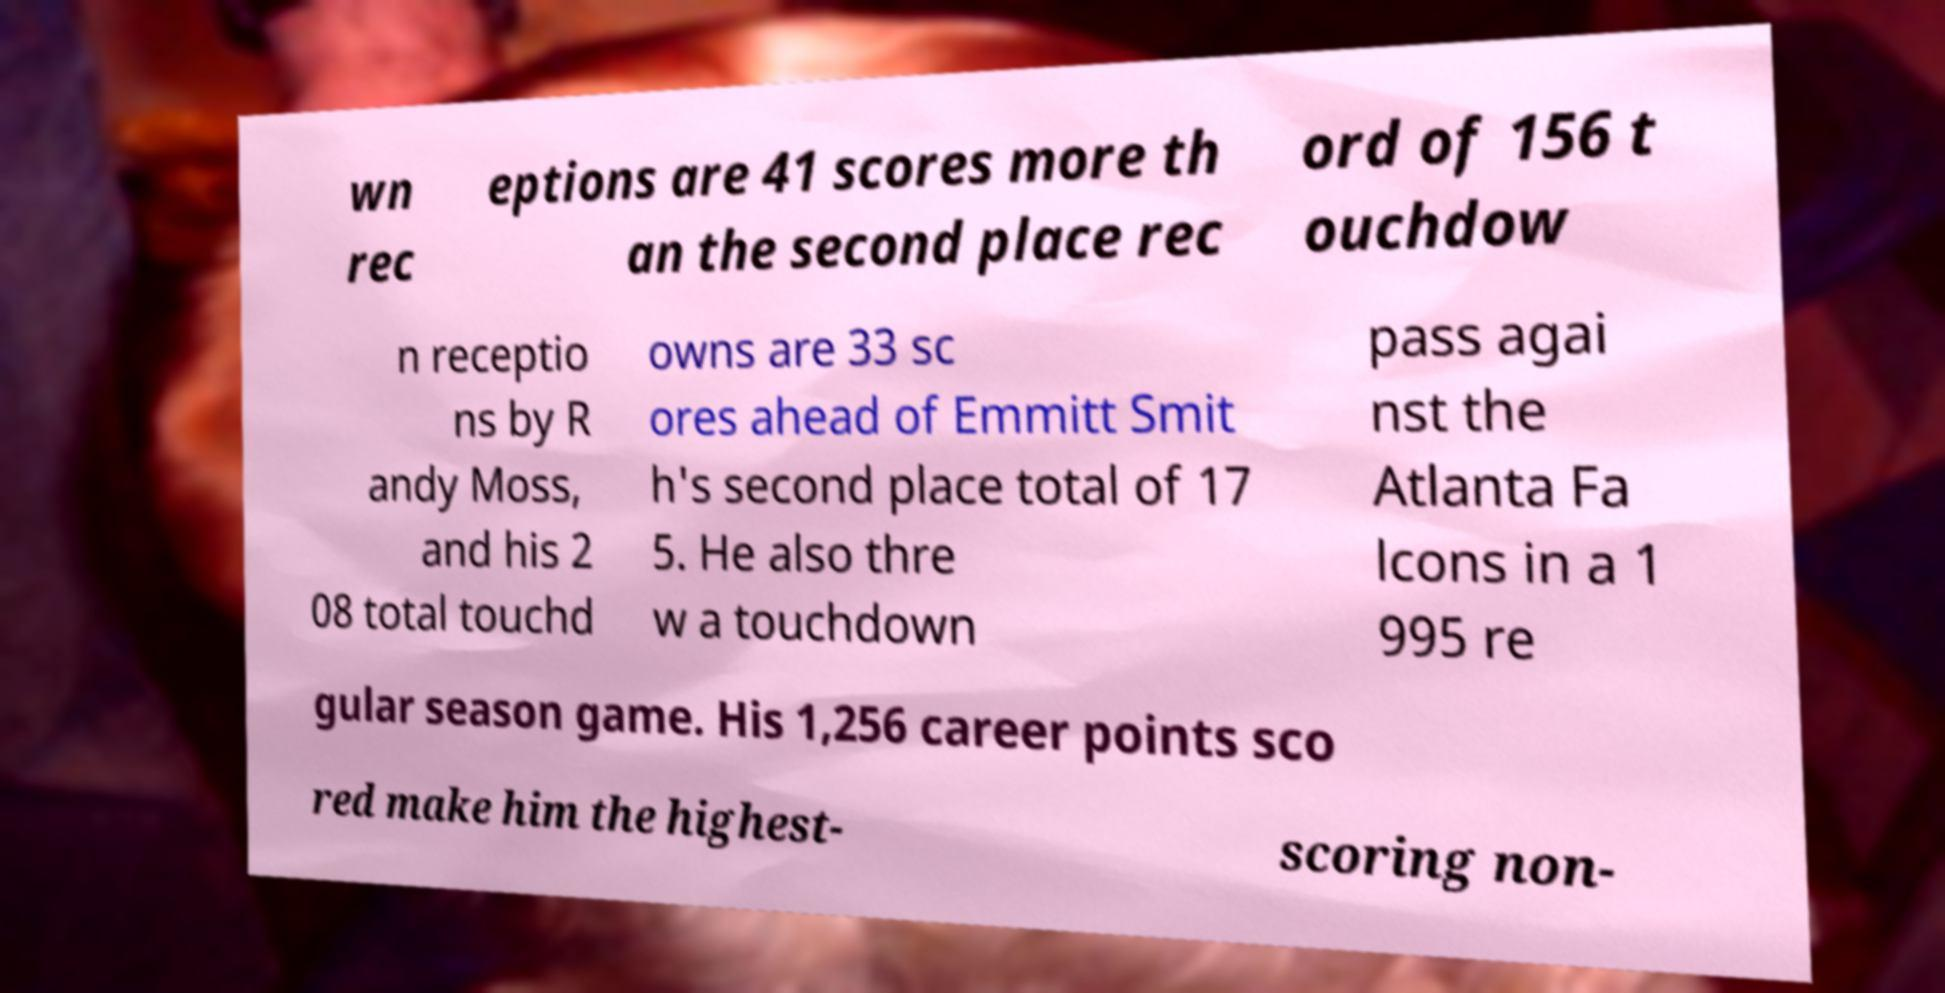Can you accurately transcribe the text from the provided image for me? wn rec eptions are 41 scores more th an the second place rec ord of 156 t ouchdow n receptio ns by R andy Moss, and his 2 08 total touchd owns are 33 sc ores ahead of Emmitt Smit h's second place total of 17 5. He also thre w a touchdown pass agai nst the Atlanta Fa lcons in a 1 995 re gular season game. His 1,256 career points sco red make him the highest- scoring non- 